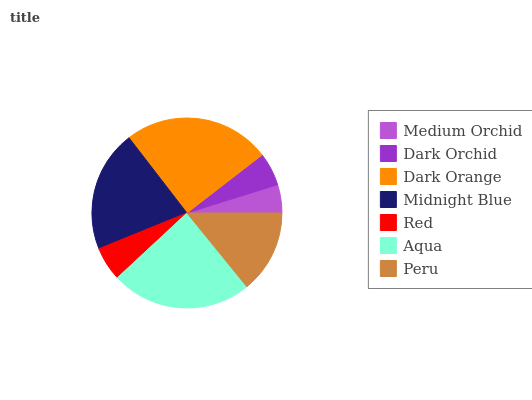Is Medium Orchid the minimum?
Answer yes or no. Yes. Is Dark Orange the maximum?
Answer yes or no. Yes. Is Dark Orchid the minimum?
Answer yes or no. No. Is Dark Orchid the maximum?
Answer yes or no. No. Is Dark Orchid greater than Medium Orchid?
Answer yes or no. Yes. Is Medium Orchid less than Dark Orchid?
Answer yes or no. Yes. Is Medium Orchid greater than Dark Orchid?
Answer yes or no. No. Is Dark Orchid less than Medium Orchid?
Answer yes or no. No. Is Peru the high median?
Answer yes or no. Yes. Is Peru the low median?
Answer yes or no. Yes. Is Dark Orange the high median?
Answer yes or no. No. Is Midnight Blue the low median?
Answer yes or no. No. 